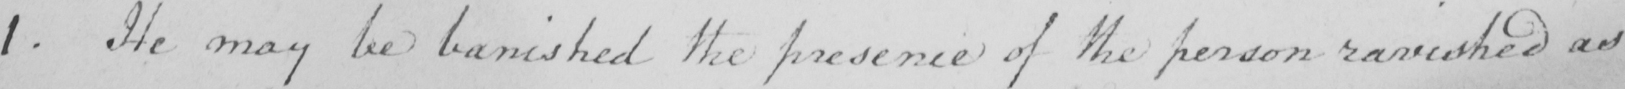Can you read and transcribe this handwriting? 1 . He may be banished the presence of the person ravished as 